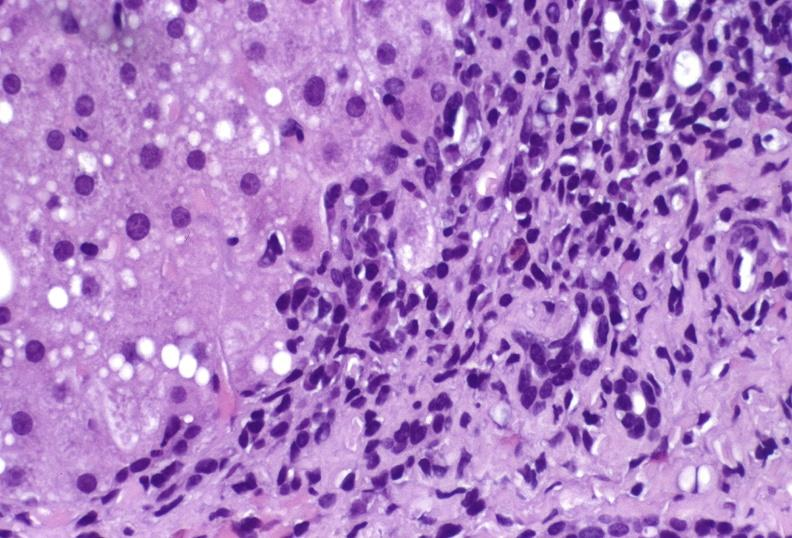what is present?
Answer the question using a single word or phrase. Hepatobiliary 